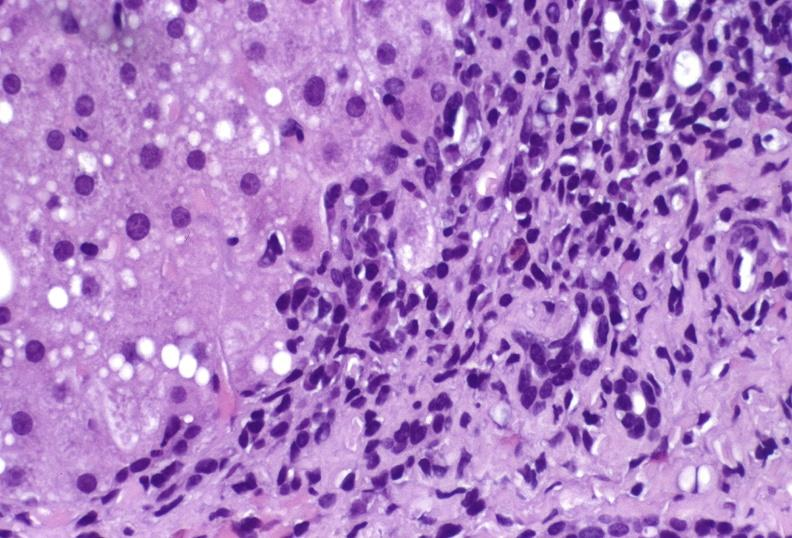what is present?
Answer the question using a single word or phrase. Hepatobiliary 